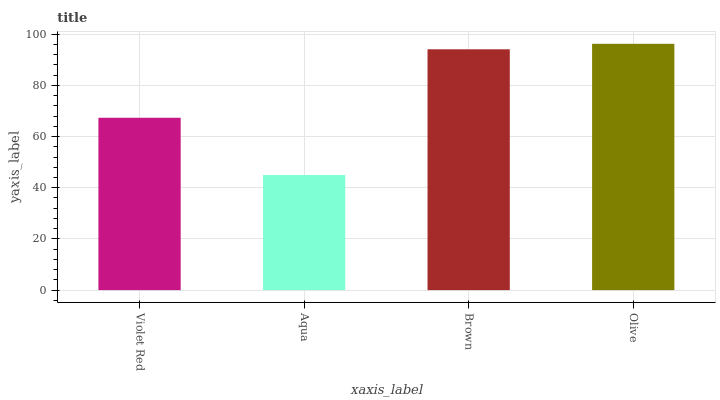Is Brown the minimum?
Answer yes or no. No. Is Brown the maximum?
Answer yes or no. No. Is Brown greater than Aqua?
Answer yes or no. Yes. Is Aqua less than Brown?
Answer yes or no. Yes. Is Aqua greater than Brown?
Answer yes or no. No. Is Brown less than Aqua?
Answer yes or no. No. Is Brown the high median?
Answer yes or no. Yes. Is Violet Red the low median?
Answer yes or no. Yes. Is Olive the high median?
Answer yes or no. No. Is Olive the low median?
Answer yes or no. No. 